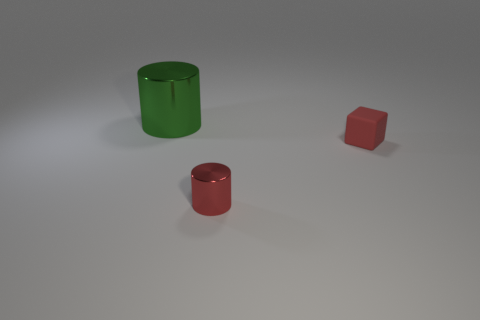Add 2 large cyan rubber cubes. How many objects exist? 5 Subtract all cylinders. How many objects are left? 1 Subtract all brown balls. How many cyan cubes are left? 0 Subtract all big metal objects. Subtract all tiny metallic things. How many objects are left? 1 Add 1 small rubber cubes. How many small rubber cubes are left? 2 Add 1 large purple cylinders. How many large purple cylinders exist? 1 Subtract 1 green cylinders. How many objects are left? 2 Subtract 1 cubes. How many cubes are left? 0 Subtract all gray cubes. Subtract all gray spheres. How many cubes are left? 1 